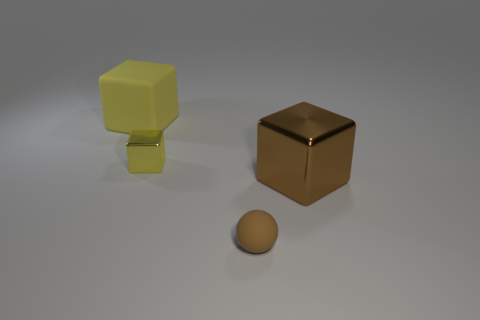There is a large matte object that is the same shape as the yellow shiny object; what is its color?
Keep it short and to the point. Yellow. What is the size of the other yellow thing that is the same shape as the small yellow thing?
Your answer should be very brief. Large. What material is the block that is on the right side of the large rubber thing and behind the large brown thing?
Ensure brevity in your answer.  Metal. Do the metallic block behind the brown metal thing and the matte cube have the same color?
Make the answer very short. Yes. There is a large rubber block; is its color the same as the metal block left of the big brown block?
Keep it short and to the point. Yes. There is a big yellow rubber object; are there any matte balls behind it?
Ensure brevity in your answer.  No. Is the small cube made of the same material as the large brown cube?
Your answer should be very brief. Yes. What is the material of the yellow thing that is the same size as the brown metallic thing?
Make the answer very short. Rubber. What number of things are either things that are on the left side of the matte ball or green metallic balls?
Keep it short and to the point. 2. Are there an equal number of big brown metal objects that are behind the big yellow thing and rubber balls?
Your response must be concise. No. 